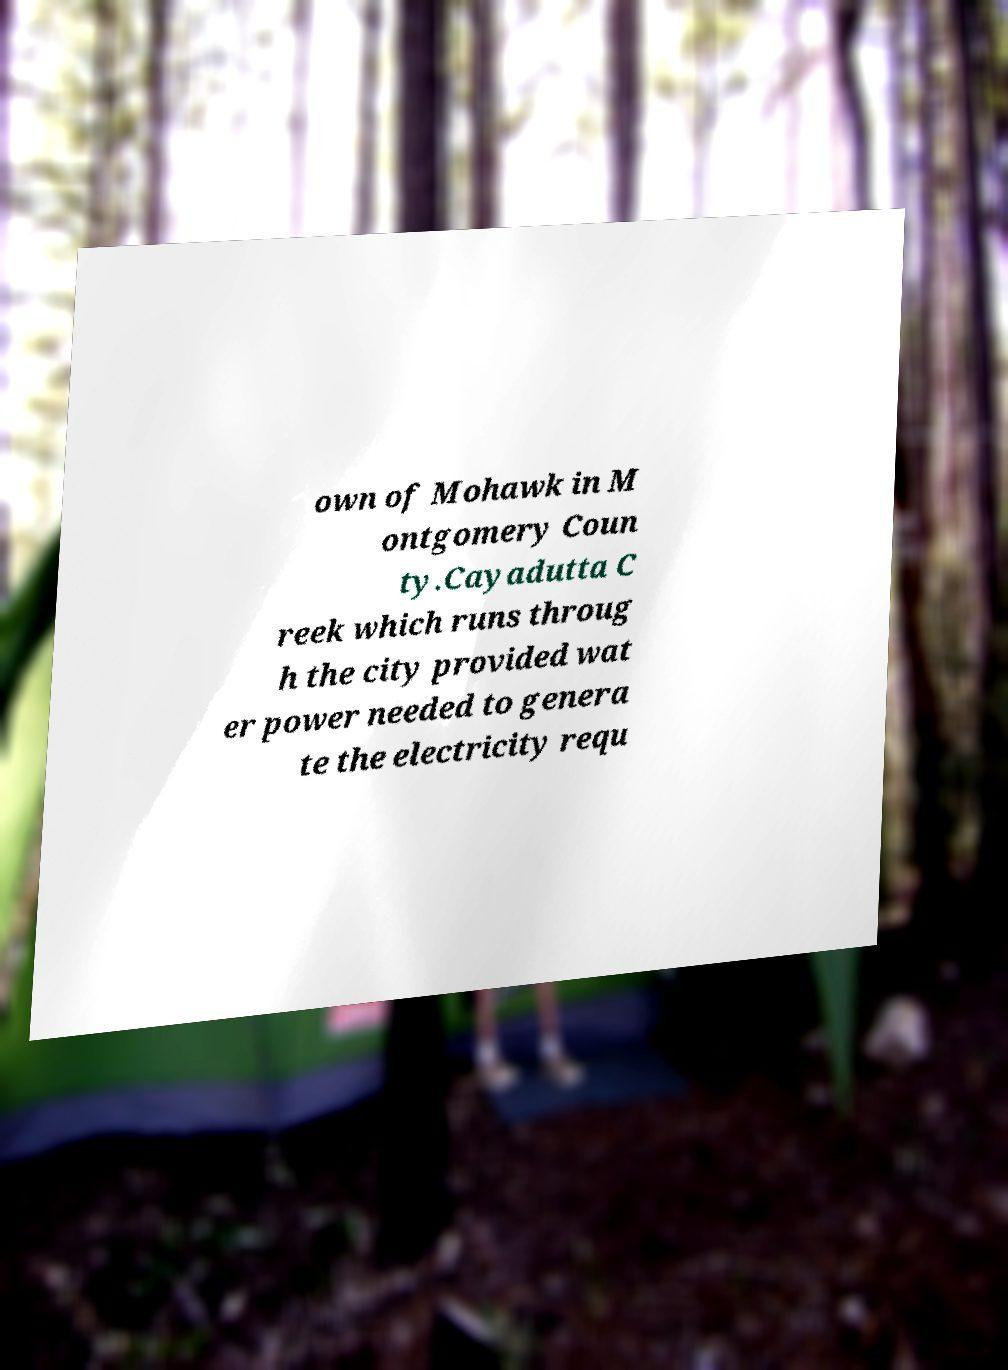Could you assist in decoding the text presented in this image and type it out clearly? own of Mohawk in M ontgomery Coun ty.Cayadutta C reek which runs throug h the city provided wat er power needed to genera te the electricity requ 